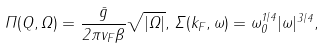<formula> <loc_0><loc_0><loc_500><loc_500>\Pi ( Q , \Omega ) = \frac { \bar { g } } { 2 \pi v _ { F } \beta } \sqrt { | \Omega | } , \, \Sigma ( k _ { F } , \omega ) = \omega _ { 0 } ^ { 1 / 4 } | \omega | ^ { 3 / 4 } ,</formula> 